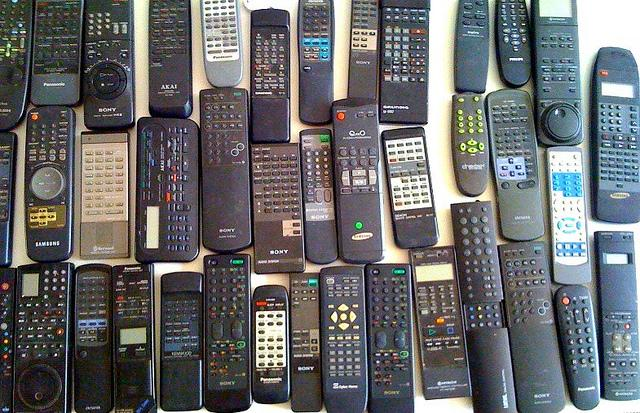Most of these items are probably used on what?

Choices:
A) televisions
B) cars
C) light fixtures
D) air conditioners televisions 